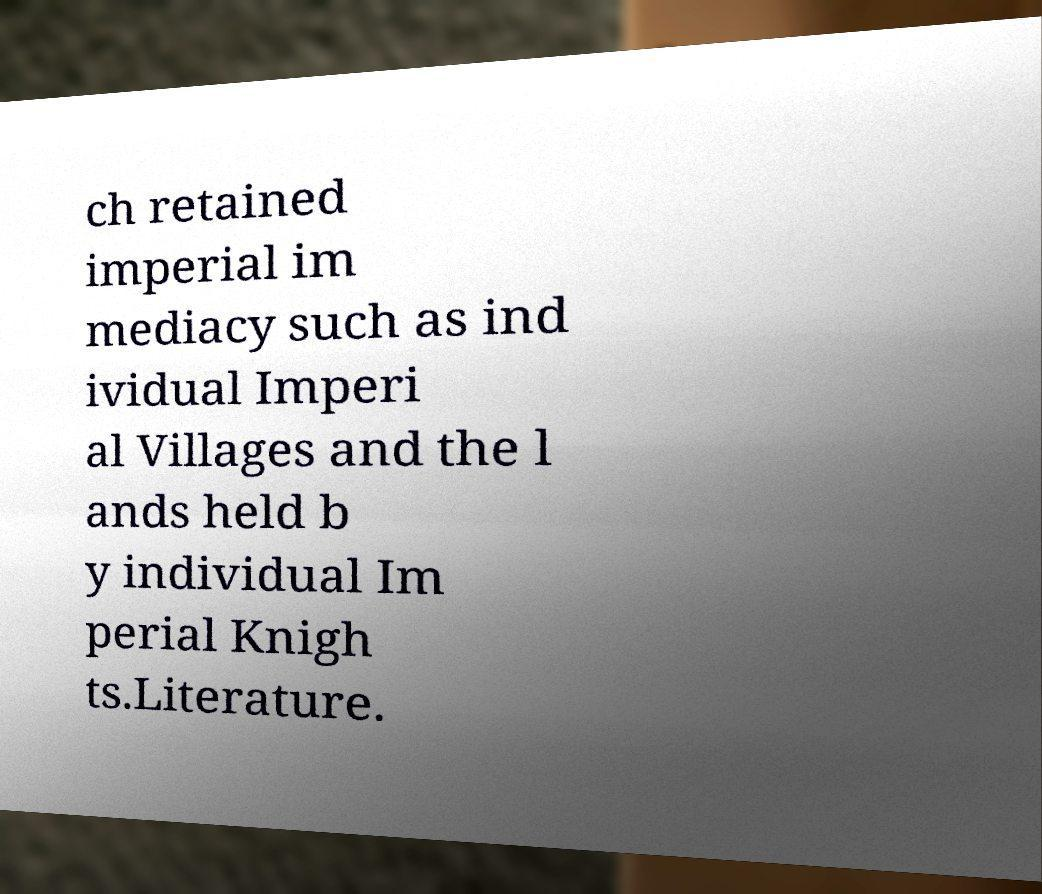I need the written content from this picture converted into text. Can you do that? ch retained imperial im mediacy such as ind ividual Imperi al Villages and the l ands held b y individual Im perial Knigh ts.Literature. 